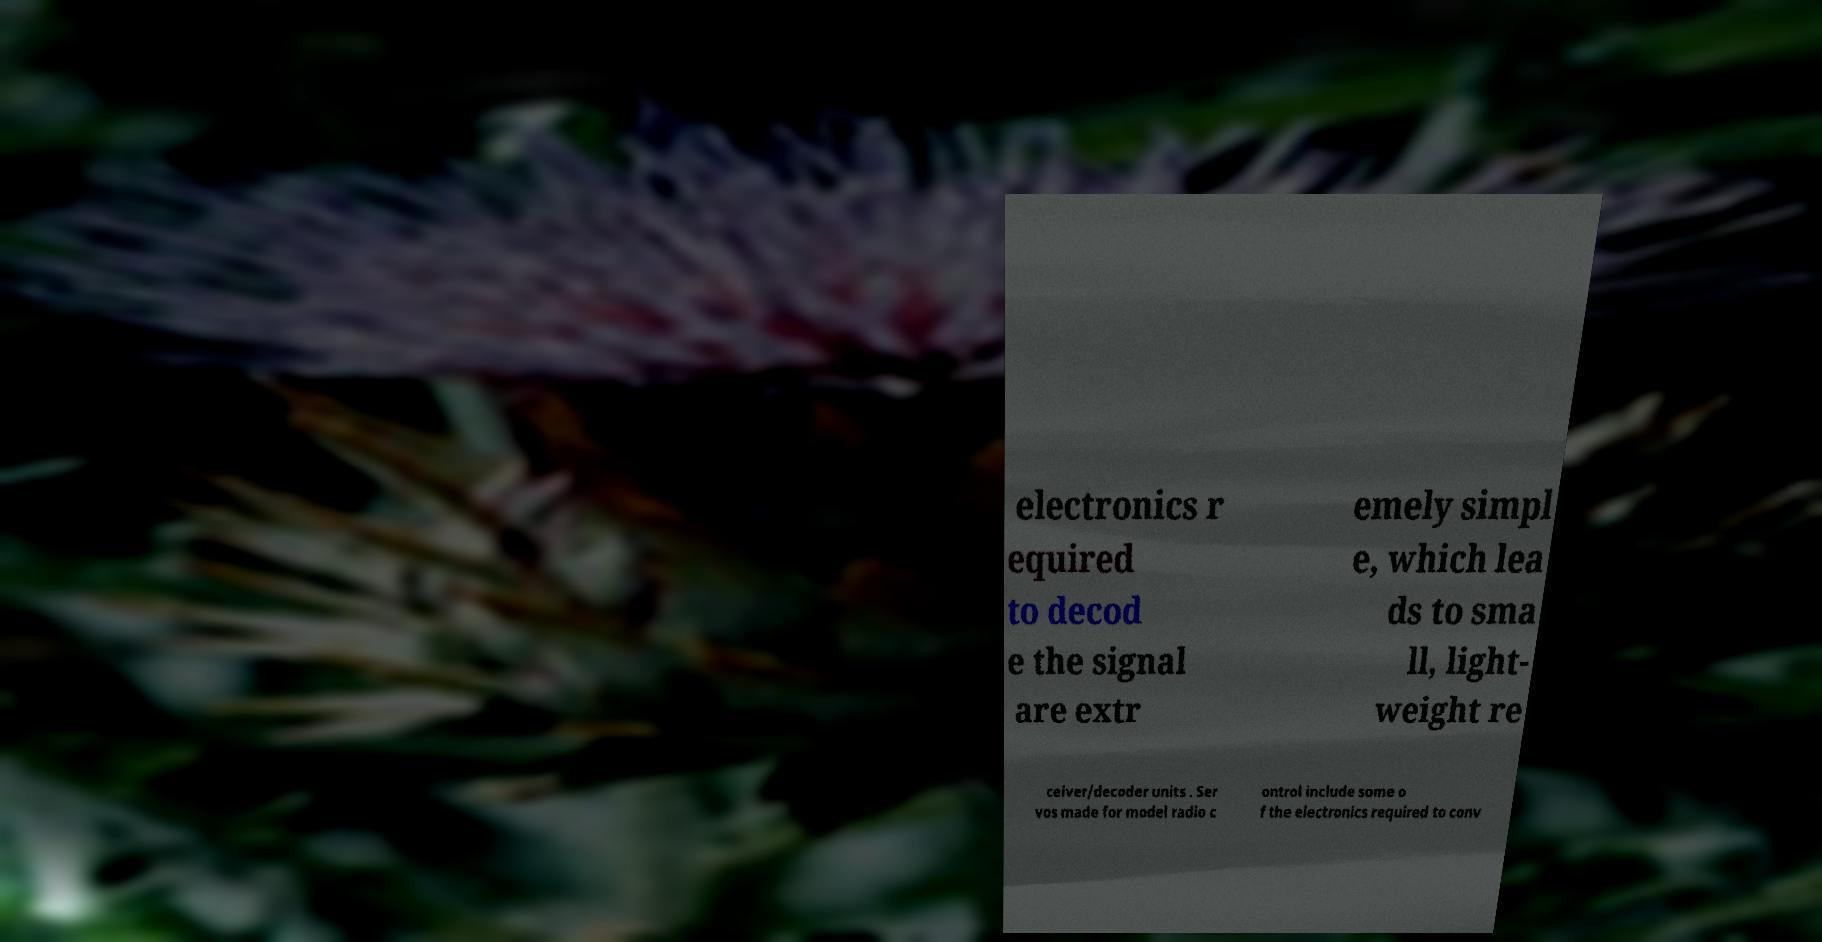There's text embedded in this image that I need extracted. Can you transcribe it verbatim? electronics r equired to decod e the signal are extr emely simpl e, which lea ds to sma ll, light- weight re ceiver/decoder units . Ser vos made for model radio c ontrol include some o f the electronics required to conv 